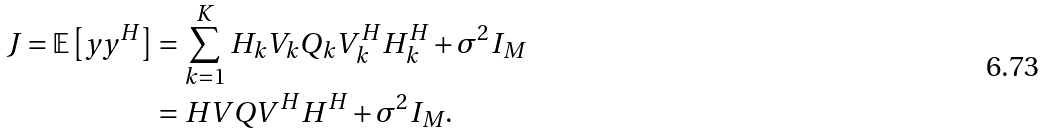<formula> <loc_0><loc_0><loc_500><loc_500>J = \mathbb { E } \left [ y y ^ { H } \right ] & = \sum _ { k = 1 } ^ { K } H _ { k } V _ { k } Q _ { k } V _ { k } ^ { H } H _ { k } ^ { H } + \sigma ^ { 2 } I _ { M } \\ & = H V Q V ^ { H } H ^ { H } + \sigma ^ { 2 } I _ { M } .</formula> 